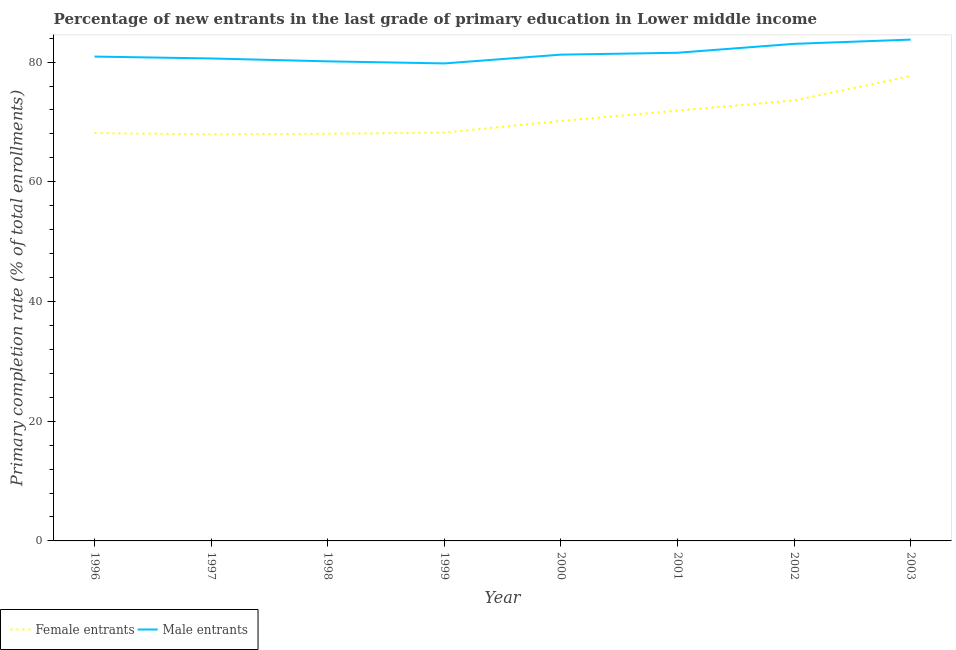What is the primary completion rate of female entrants in 1998?
Keep it short and to the point. 68.03. Across all years, what is the maximum primary completion rate of female entrants?
Ensure brevity in your answer.  77.67. Across all years, what is the minimum primary completion rate of male entrants?
Offer a very short reply. 79.77. In which year was the primary completion rate of male entrants maximum?
Your answer should be compact. 2003. What is the total primary completion rate of female entrants in the graph?
Offer a very short reply. 565.61. What is the difference between the primary completion rate of male entrants in 1996 and that in 2002?
Your answer should be very brief. -2.13. What is the difference between the primary completion rate of female entrants in 1999 and the primary completion rate of male entrants in 2003?
Your response must be concise. -15.53. What is the average primary completion rate of male entrants per year?
Give a very brief answer. 81.38. In the year 1996, what is the difference between the primary completion rate of male entrants and primary completion rate of female entrants?
Your answer should be very brief. 12.78. What is the ratio of the primary completion rate of male entrants in 1996 to that in 2003?
Offer a terse response. 0.97. Is the primary completion rate of female entrants in 1997 less than that in 2000?
Your answer should be compact. Yes. What is the difference between the highest and the second highest primary completion rate of female entrants?
Keep it short and to the point. 4.08. What is the difference between the highest and the lowest primary completion rate of female entrants?
Give a very brief answer. 9.74. In how many years, is the primary completion rate of male entrants greater than the average primary completion rate of male entrants taken over all years?
Provide a succinct answer. 3. Is the sum of the primary completion rate of male entrants in 1996 and 1997 greater than the maximum primary completion rate of female entrants across all years?
Keep it short and to the point. Yes. Does the primary completion rate of male entrants monotonically increase over the years?
Your answer should be compact. No. Is the primary completion rate of female entrants strictly greater than the primary completion rate of male entrants over the years?
Give a very brief answer. No. How many years are there in the graph?
Offer a very short reply. 8. What is the difference between two consecutive major ticks on the Y-axis?
Your answer should be very brief. 20. Are the values on the major ticks of Y-axis written in scientific E-notation?
Your answer should be compact. No. Does the graph contain any zero values?
Give a very brief answer. No. Where does the legend appear in the graph?
Offer a very short reply. Bottom left. What is the title of the graph?
Provide a short and direct response. Percentage of new entrants in the last grade of primary education in Lower middle income. Does "Quasi money growth" appear as one of the legend labels in the graph?
Provide a short and direct response. No. What is the label or title of the Y-axis?
Provide a short and direct response. Primary completion rate (% of total enrollments). What is the Primary completion rate (% of total enrollments) of Female entrants in 1996?
Give a very brief answer. 68.14. What is the Primary completion rate (% of total enrollments) in Male entrants in 1996?
Offer a terse response. 80.92. What is the Primary completion rate (% of total enrollments) in Female entrants in 1997?
Your answer should be compact. 67.92. What is the Primary completion rate (% of total enrollments) of Male entrants in 1997?
Keep it short and to the point. 80.6. What is the Primary completion rate (% of total enrollments) of Female entrants in 1998?
Offer a very short reply. 68.03. What is the Primary completion rate (% of total enrollments) in Male entrants in 1998?
Give a very brief answer. 80.12. What is the Primary completion rate (% of total enrollments) of Female entrants in 1999?
Your response must be concise. 68.22. What is the Primary completion rate (% of total enrollments) in Male entrants in 1999?
Your answer should be very brief. 79.77. What is the Primary completion rate (% of total enrollments) in Female entrants in 2000?
Keep it short and to the point. 70.16. What is the Primary completion rate (% of total enrollments) in Male entrants in 2000?
Give a very brief answer. 81.24. What is the Primary completion rate (% of total enrollments) of Female entrants in 2001?
Give a very brief answer. 71.9. What is the Primary completion rate (% of total enrollments) of Male entrants in 2001?
Offer a very short reply. 81.55. What is the Primary completion rate (% of total enrollments) of Female entrants in 2002?
Provide a short and direct response. 73.58. What is the Primary completion rate (% of total enrollments) of Male entrants in 2002?
Give a very brief answer. 83.04. What is the Primary completion rate (% of total enrollments) in Female entrants in 2003?
Keep it short and to the point. 77.67. What is the Primary completion rate (% of total enrollments) in Male entrants in 2003?
Ensure brevity in your answer.  83.75. Across all years, what is the maximum Primary completion rate (% of total enrollments) in Female entrants?
Offer a terse response. 77.67. Across all years, what is the maximum Primary completion rate (% of total enrollments) in Male entrants?
Provide a succinct answer. 83.75. Across all years, what is the minimum Primary completion rate (% of total enrollments) in Female entrants?
Offer a very short reply. 67.92. Across all years, what is the minimum Primary completion rate (% of total enrollments) in Male entrants?
Your answer should be very brief. 79.77. What is the total Primary completion rate (% of total enrollments) in Female entrants in the graph?
Your answer should be compact. 565.61. What is the total Primary completion rate (% of total enrollments) in Male entrants in the graph?
Keep it short and to the point. 651.01. What is the difference between the Primary completion rate (% of total enrollments) in Female entrants in 1996 and that in 1997?
Your response must be concise. 0.21. What is the difference between the Primary completion rate (% of total enrollments) of Male entrants in 1996 and that in 1997?
Your response must be concise. 0.31. What is the difference between the Primary completion rate (% of total enrollments) of Female entrants in 1996 and that in 1998?
Your answer should be compact. 0.11. What is the difference between the Primary completion rate (% of total enrollments) in Male entrants in 1996 and that in 1998?
Offer a very short reply. 0.8. What is the difference between the Primary completion rate (% of total enrollments) in Female entrants in 1996 and that in 1999?
Offer a very short reply. -0.08. What is the difference between the Primary completion rate (% of total enrollments) of Male entrants in 1996 and that in 1999?
Your answer should be very brief. 1.14. What is the difference between the Primary completion rate (% of total enrollments) in Female entrants in 1996 and that in 2000?
Your answer should be very brief. -2.02. What is the difference between the Primary completion rate (% of total enrollments) of Male entrants in 1996 and that in 2000?
Give a very brief answer. -0.33. What is the difference between the Primary completion rate (% of total enrollments) in Female entrants in 1996 and that in 2001?
Provide a short and direct response. -3.76. What is the difference between the Primary completion rate (% of total enrollments) in Male entrants in 1996 and that in 2001?
Give a very brief answer. -0.64. What is the difference between the Primary completion rate (% of total enrollments) of Female entrants in 1996 and that in 2002?
Give a very brief answer. -5.44. What is the difference between the Primary completion rate (% of total enrollments) in Male entrants in 1996 and that in 2002?
Offer a terse response. -2.13. What is the difference between the Primary completion rate (% of total enrollments) of Female entrants in 1996 and that in 2003?
Make the answer very short. -9.53. What is the difference between the Primary completion rate (% of total enrollments) in Male entrants in 1996 and that in 2003?
Your answer should be compact. -2.84. What is the difference between the Primary completion rate (% of total enrollments) in Female entrants in 1997 and that in 1998?
Offer a very short reply. -0.1. What is the difference between the Primary completion rate (% of total enrollments) in Male entrants in 1997 and that in 1998?
Your answer should be very brief. 0.48. What is the difference between the Primary completion rate (% of total enrollments) of Female entrants in 1997 and that in 1999?
Offer a terse response. -0.3. What is the difference between the Primary completion rate (% of total enrollments) of Male entrants in 1997 and that in 1999?
Ensure brevity in your answer.  0.83. What is the difference between the Primary completion rate (% of total enrollments) of Female entrants in 1997 and that in 2000?
Offer a very short reply. -2.24. What is the difference between the Primary completion rate (% of total enrollments) of Male entrants in 1997 and that in 2000?
Ensure brevity in your answer.  -0.64. What is the difference between the Primary completion rate (% of total enrollments) in Female entrants in 1997 and that in 2001?
Your answer should be very brief. -3.98. What is the difference between the Primary completion rate (% of total enrollments) of Male entrants in 1997 and that in 2001?
Your response must be concise. -0.95. What is the difference between the Primary completion rate (% of total enrollments) in Female entrants in 1997 and that in 2002?
Your answer should be very brief. -5.66. What is the difference between the Primary completion rate (% of total enrollments) in Male entrants in 1997 and that in 2002?
Your response must be concise. -2.44. What is the difference between the Primary completion rate (% of total enrollments) in Female entrants in 1997 and that in 2003?
Keep it short and to the point. -9.74. What is the difference between the Primary completion rate (% of total enrollments) of Male entrants in 1997 and that in 2003?
Ensure brevity in your answer.  -3.15. What is the difference between the Primary completion rate (% of total enrollments) of Female entrants in 1998 and that in 1999?
Your answer should be very brief. -0.19. What is the difference between the Primary completion rate (% of total enrollments) of Male entrants in 1998 and that in 1999?
Keep it short and to the point. 0.35. What is the difference between the Primary completion rate (% of total enrollments) of Female entrants in 1998 and that in 2000?
Your answer should be compact. -2.13. What is the difference between the Primary completion rate (% of total enrollments) in Male entrants in 1998 and that in 2000?
Your answer should be compact. -1.12. What is the difference between the Primary completion rate (% of total enrollments) of Female entrants in 1998 and that in 2001?
Offer a very short reply. -3.87. What is the difference between the Primary completion rate (% of total enrollments) in Male entrants in 1998 and that in 2001?
Give a very brief answer. -1.43. What is the difference between the Primary completion rate (% of total enrollments) of Female entrants in 1998 and that in 2002?
Give a very brief answer. -5.55. What is the difference between the Primary completion rate (% of total enrollments) in Male entrants in 1998 and that in 2002?
Give a very brief answer. -2.92. What is the difference between the Primary completion rate (% of total enrollments) of Female entrants in 1998 and that in 2003?
Provide a short and direct response. -9.64. What is the difference between the Primary completion rate (% of total enrollments) of Male entrants in 1998 and that in 2003?
Provide a short and direct response. -3.63. What is the difference between the Primary completion rate (% of total enrollments) of Female entrants in 1999 and that in 2000?
Provide a succinct answer. -1.94. What is the difference between the Primary completion rate (% of total enrollments) of Male entrants in 1999 and that in 2000?
Your response must be concise. -1.47. What is the difference between the Primary completion rate (% of total enrollments) in Female entrants in 1999 and that in 2001?
Offer a very short reply. -3.68. What is the difference between the Primary completion rate (% of total enrollments) in Male entrants in 1999 and that in 2001?
Offer a very short reply. -1.78. What is the difference between the Primary completion rate (% of total enrollments) of Female entrants in 1999 and that in 2002?
Provide a succinct answer. -5.36. What is the difference between the Primary completion rate (% of total enrollments) in Male entrants in 1999 and that in 2002?
Keep it short and to the point. -3.27. What is the difference between the Primary completion rate (% of total enrollments) of Female entrants in 1999 and that in 2003?
Your response must be concise. -9.45. What is the difference between the Primary completion rate (% of total enrollments) of Male entrants in 1999 and that in 2003?
Offer a very short reply. -3.98. What is the difference between the Primary completion rate (% of total enrollments) of Female entrants in 2000 and that in 2001?
Make the answer very short. -1.74. What is the difference between the Primary completion rate (% of total enrollments) of Male entrants in 2000 and that in 2001?
Ensure brevity in your answer.  -0.31. What is the difference between the Primary completion rate (% of total enrollments) in Female entrants in 2000 and that in 2002?
Offer a terse response. -3.42. What is the difference between the Primary completion rate (% of total enrollments) of Male entrants in 2000 and that in 2002?
Keep it short and to the point. -1.8. What is the difference between the Primary completion rate (% of total enrollments) in Female entrants in 2000 and that in 2003?
Offer a very short reply. -7.51. What is the difference between the Primary completion rate (% of total enrollments) of Male entrants in 2000 and that in 2003?
Make the answer very short. -2.51. What is the difference between the Primary completion rate (% of total enrollments) of Female entrants in 2001 and that in 2002?
Offer a terse response. -1.68. What is the difference between the Primary completion rate (% of total enrollments) in Male entrants in 2001 and that in 2002?
Provide a succinct answer. -1.49. What is the difference between the Primary completion rate (% of total enrollments) of Female entrants in 2001 and that in 2003?
Provide a short and direct response. -5.77. What is the difference between the Primary completion rate (% of total enrollments) in Male entrants in 2001 and that in 2003?
Provide a short and direct response. -2.2. What is the difference between the Primary completion rate (% of total enrollments) in Female entrants in 2002 and that in 2003?
Make the answer very short. -4.08. What is the difference between the Primary completion rate (% of total enrollments) in Male entrants in 2002 and that in 2003?
Ensure brevity in your answer.  -0.71. What is the difference between the Primary completion rate (% of total enrollments) in Female entrants in 1996 and the Primary completion rate (% of total enrollments) in Male entrants in 1997?
Make the answer very short. -12.47. What is the difference between the Primary completion rate (% of total enrollments) of Female entrants in 1996 and the Primary completion rate (% of total enrollments) of Male entrants in 1998?
Your answer should be compact. -11.98. What is the difference between the Primary completion rate (% of total enrollments) in Female entrants in 1996 and the Primary completion rate (% of total enrollments) in Male entrants in 1999?
Offer a very short reply. -11.64. What is the difference between the Primary completion rate (% of total enrollments) of Female entrants in 1996 and the Primary completion rate (% of total enrollments) of Male entrants in 2000?
Keep it short and to the point. -13.1. What is the difference between the Primary completion rate (% of total enrollments) in Female entrants in 1996 and the Primary completion rate (% of total enrollments) in Male entrants in 2001?
Your answer should be very brief. -13.42. What is the difference between the Primary completion rate (% of total enrollments) in Female entrants in 1996 and the Primary completion rate (% of total enrollments) in Male entrants in 2002?
Make the answer very short. -14.91. What is the difference between the Primary completion rate (% of total enrollments) of Female entrants in 1996 and the Primary completion rate (% of total enrollments) of Male entrants in 2003?
Provide a short and direct response. -15.62. What is the difference between the Primary completion rate (% of total enrollments) in Female entrants in 1997 and the Primary completion rate (% of total enrollments) in Male entrants in 1998?
Make the answer very short. -12.2. What is the difference between the Primary completion rate (% of total enrollments) in Female entrants in 1997 and the Primary completion rate (% of total enrollments) in Male entrants in 1999?
Provide a succinct answer. -11.85. What is the difference between the Primary completion rate (% of total enrollments) in Female entrants in 1997 and the Primary completion rate (% of total enrollments) in Male entrants in 2000?
Ensure brevity in your answer.  -13.32. What is the difference between the Primary completion rate (% of total enrollments) of Female entrants in 1997 and the Primary completion rate (% of total enrollments) of Male entrants in 2001?
Your answer should be compact. -13.63. What is the difference between the Primary completion rate (% of total enrollments) of Female entrants in 1997 and the Primary completion rate (% of total enrollments) of Male entrants in 2002?
Give a very brief answer. -15.12. What is the difference between the Primary completion rate (% of total enrollments) of Female entrants in 1997 and the Primary completion rate (% of total enrollments) of Male entrants in 2003?
Provide a short and direct response. -15.83. What is the difference between the Primary completion rate (% of total enrollments) of Female entrants in 1998 and the Primary completion rate (% of total enrollments) of Male entrants in 1999?
Your answer should be very brief. -11.75. What is the difference between the Primary completion rate (% of total enrollments) of Female entrants in 1998 and the Primary completion rate (% of total enrollments) of Male entrants in 2000?
Provide a short and direct response. -13.22. What is the difference between the Primary completion rate (% of total enrollments) of Female entrants in 1998 and the Primary completion rate (% of total enrollments) of Male entrants in 2001?
Ensure brevity in your answer.  -13.53. What is the difference between the Primary completion rate (% of total enrollments) of Female entrants in 1998 and the Primary completion rate (% of total enrollments) of Male entrants in 2002?
Your response must be concise. -15.02. What is the difference between the Primary completion rate (% of total enrollments) of Female entrants in 1998 and the Primary completion rate (% of total enrollments) of Male entrants in 2003?
Provide a succinct answer. -15.73. What is the difference between the Primary completion rate (% of total enrollments) of Female entrants in 1999 and the Primary completion rate (% of total enrollments) of Male entrants in 2000?
Make the answer very short. -13.02. What is the difference between the Primary completion rate (% of total enrollments) of Female entrants in 1999 and the Primary completion rate (% of total enrollments) of Male entrants in 2001?
Your answer should be very brief. -13.34. What is the difference between the Primary completion rate (% of total enrollments) in Female entrants in 1999 and the Primary completion rate (% of total enrollments) in Male entrants in 2002?
Give a very brief answer. -14.82. What is the difference between the Primary completion rate (% of total enrollments) of Female entrants in 1999 and the Primary completion rate (% of total enrollments) of Male entrants in 2003?
Offer a terse response. -15.53. What is the difference between the Primary completion rate (% of total enrollments) in Female entrants in 2000 and the Primary completion rate (% of total enrollments) in Male entrants in 2001?
Your response must be concise. -11.39. What is the difference between the Primary completion rate (% of total enrollments) in Female entrants in 2000 and the Primary completion rate (% of total enrollments) in Male entrants in 2002?
Ensure brevity in your answer.  -12.88. What is the difference between the Primary completion rate (% of total enrollments) of Female entrants in 2000 and the Primary completion rate (% of total enrollments) of Male entrants in 2003?
Provide a short and direct response. -13.59. What is the difference between the Primary completion rate (% of total enrollments) of Female entrants in 2001 and the Primary completion rate (% of total enrollments) of Male entrants in 2002?
Your answer should be compact. -11.14. What is the difference between the Primary completion rate (% of total enrollments) in Female entrants in 2001 and the Primary completion rate (% of total enrollments) in Male entrants in 2003?
Offer a terse response. -11.85. What is the difference between the Primary completion rate (% of total enrollments) in Female entrants in 2002 and the Primary completion rate (% of total enrollments) in Male entrants in 2003?
Offer a very short reply. -10.17. What is the average Primary completion rate (% of total enrollments) of Female entrants per year?
Make the answer very short. 70.7. What is the average Primary completion rate (% of total enrollments) of Male entrants per year?
Your answer should be compact. 81.38. In the year 1996, what is the difference between the Primary completion rate (% of total enrollments) in Female entrants and Primary completion rate (% of total enrollments) in Male entrants?
Provide a succinct answer. -12.78. In the year 1997, what is the difference between the Primary completion rate (% of total enrollments) in Female entrants and Primary completion rate (% of total enrollments) in Male entrants?
Offer a very short reply. -12.68. In the year 1998, what is the difference between the Primary completion rate (% of total enrollments) in Female entrants and Primary completion rate (% of total enrollments) in Male entrants?
Ensure brevity in your answer.  -12.09. In the year 1999, what is the difference between the Primary completion rate (% of total enrollments) of Female entrants and Primary completion rate (% of total enrollments) of Male entrants?
Offer a very short reply. -11.55. In the year 2000, what is the difference between the Primary completion rate (% of total enrollments) of Female entrants and Primary completion rate (% of total enrollments) of Male entrants?
Offer a very short reply. -11.08. In the year 2001, what is the difference between the Primary completion rate (% of total enrollments) in Female entrants and Primary completion rate (% of total enrollments) in Male entrants?
Offer a terse response. -9.65. In the year 2002, what is the difference between the Primary completion rate (% of total enrollments) of Female entrants and Primary completion rate (% of total enrollments) of Male entrants?
Provide a short and direct response. -9.46. In the year 2003, what is the difference between the Primary completion rate (% of total enrollments) in Female entrants and Primary completion rate (% of total enrollments) in Male entrants?
Ensure brevity in your answer.  -6.09. What is the ratio of the Primary completion rate (% of total enrollments) in Female entrants in 1996 to that in 1997?
Your answer should be compact. 1. What is the ratio of the Primary completion rate (% of total enrollments) of Male entrants in 1996 to that in 1997?
Keep it short and to the point. 1. What is the ratio of the Primary completion rate (% of total enrollments) of Female entrants in 1996 to that in 1998?
Ensure brevity in your answer.  1. What is the ratio of the Primary completion rate (% of total enrollments) of Male entrants in 1996 to that in 1998?
Ensure brevity in your answer.  1.01. What is the ratio of the Primary completion rate (% of total enrollments) in Female entrants in 1996 to that in 1999?
Keep it short and to the point. 1. What is the ratio of the Primary completion rate (% of total enrollments) of Male entrants in 1996 to that in 1999?
Provide a short and direct response. 1.01. What is the ratio of the Primary completion rate (% of total enrollments) of Female entrants in 1996 to that in 2000?
Your answer should be compact. 0.97. What is the ratio of the Primary completion rate (% of total enrollments) in Male entrants in 1996 to that in 2000?
Keep it short and to the point. 1. What is the ratio of the Primary completion rate (% of total enrollments) in Female entrants in 1996 to that in 2001?
Your answer should be very brief. 0.95. What is the ratio of the Primary completion rate (% of total enrollments) in Male entrants in 1996 to that in 2001?
Your answer should be very brief. 0.99. What is the ratio of the Primary completion rate (% of total enrollments) of Female entrants in 1996 to that in 2002?
Offer a very short reply. 0.93. What is the ratio of the Primary completion rate (% of total enrollments) of Male entrants in 1996 to that in 2002?
Keep it short and to the point. 0.97. What is the ratio of the Primary completion rate (% of total enrollments) in Female entrants in 1996 to that in 2003?
Give a very brief answer. 0.88. What is the ratio of the Primary completion rate (% of total enrollments) in Male entrants in 1996 to that in 2003?
Provide a succinct answer. 0.97. What is the ratio of the Primary completion rate (% of total enrollments) of Female entrants in 1997 to that in 1998?
Make the answer very short. 1. What is the ratio of the Primary completion rate (% of total enrollments) in Male entrants in 1997 to that in 1999?
Ensure brevity in your answer.  1.01. What is the ratio of the Primary completion rate (% of total enrollments) of Female entrants in 1997 to that in 2000?
Ensure brevity in your answer.  0.97. What is the ratio of the Primary completion rate (% of total enrollments) of Male entrants in 1997 to that in 2000?
Ensure brevity in your answer.  0.99. What is the ratio of the Primary completion rate (% of total enrollments) in Female entrants in 1997 to that in 2001?
Make the answer very short. 0.94. What is the ratio of the Primary completion rate (% of total enrollments) of Male entrants in 1997 to that in 2001?
Your answer should be compact. 0.99. What is the ratio of the Primary completion rate (% of total enrollments) in Female entrants in 1997 to that in 2002?
Offer a very short reply. 0.92. What is the ratio of the Primary completion rate (% of total enrollments) of Male entrants in 1997 to that in 2002?
Provide a succinct answer. 0.97. What is the ratio of the Primary completion rate (% of total enrollments) in Female entrants in 1997 to that in 2003?
Offer a terse response. 0.87. What is the ratio of the Primary completion rate (% of total enrollments) of Male entrants in 1997 to that in 2003?
Make the answer very short. 0.96. What is the ratio of the Primary completion rate (% of total enrollments) in Male entrants in 1998 to that in 1999?
Your answer should be compact. 1. What is the ratio of the Primary completion rate (% of total enrollments) in Female entrants in 1998 to that in 2000?
Ensure brevity in your answer.  0.97. What is the ratio of the Primary completion rate (% of total enrollments) of Male entrants in 1998 to that in 2000?
Your response must be concise. 0.99. What is the ratio of the Primary completion rate (% of total enrollments) in Female entrants in 1998 to that in 2001?
Keep it short and to the point. 0.95. What is the ratio of the Primary completion rate (% of total enrollments) in Male entrants in 1998 to that in 2001?
Offer a very short reply. 0.98. What is the ratio of the Primary completion rate (% of total enrollments) in Female entrants in 1998 to that in 2002?
Your response must be concise. 0.92. What is the ratio of the Primary completion rate (% of total enrollments) of Male entrants in 1998 to that in 2002?
Make the answer very short. 0.96. What is the ratio of the Primary completion rate (% of total enrollments) in Female entrants in 1998 to that in 2003?
Your answer should be compact. 0.88. What is the ratio of the Primary completion rate (% of total enrollments) in Male entrants in 1998 to that in 2003?
Your answer should be very brief. 0.96. What is the ratio of the Primary completion rate (% of total enrollments) in Female entrants in 1999 to that in 2000?
Offer a very short reply. 0.97. What is the ratio of the Primary completion rate (% of total enrollments) of Male entrants in 1999 to that in 2000?
Provide a short and direct response. 0.98. What is the ratio of the Primary completion rate (% of total enrollments) of Female entrants in 1999 to that in 2001?
Make the answer very short. 0.95. What is the ratio of the Primary completion rate (% of total enrollments) in Male entrants in 1999 to that in 2001?
Provide a succinct answer. 0.98. What is the ratio of the Primary completion rate (% of total enrollments) in Female entrants in 1999 to that in 2002?
Offer a very short reply. 0.93. What is the ratio of the Primary completion rate (% of total enrollments) of Male entrants in 1999 to that in 2002?
Make the answer very short. 0.96. What is the ratio of the Primary completion rate (% of total enrollments) in Female entrants in 1999 to that in 2003?
Provide a succinct answer. 0.88. What is the ratio of the Primary completion rate (% of total enrollments) of Male entrants in 1999 to that in 2003?
Offer a terse response. 0.95. What is the ratio of the Primary completion rate (% of total enrollments) in Female entrants in 2000 to that in 2001?
Your response must be concise. 0.98. What is the ratio of the Primary completion rate (% of total enrollments) in Female entrants in 2000 to that in 2002?
Provide a short and direct response. 0.95. What is the ratio of the Primary completion rate (% of total enrollments) of Male entrants in 2000 to that in 2002?
Offer a terse response. 0.98. What is the ratio of the Primary completion rate (% of total enrollments) in Female entrants in 2000 to that in 2003?
Give a very brief answer. 0.9. What is the ratio of the Primary completion rate (% of total enrollments) of Female entrants in 2001 to that in 2002?
Offer a terse response. 0.98. What is the ratio of the Primary completion rate (% of total enrollments) of Male entrants in 2001 to that in 2002?
Keep it short and to the point. 0.98. What is the ratio of the Primary completion rate (% of total enrollments) of Female entrants in 2001 to that in 2003?
Provide a succinct answer. 0.93. What is the ratio of the Primary completion rate (% of total enrollments) in Male entrants in 2001 to that in 2003?
Give a very brief answer. 0.97. What is the ratio of the Primary completion rate (% of total enrollments) of Female entrants in 2002 to that in 2003?
Keep it short and to the point. 0.95. What is the ratio of the Primary completion rate (% of total enrollments) of Male entrants in 2002 to that in 2003?
Make the answer very short. 0.99. What is the difference between the highest and the second highest Primary completion rate (% of total enrollments) of Female entrants?
Give a very brief answer. 4.08. What is the difference between the highest and the second highest Primary completion rate (% of total enrollments) in Male entrants?
Make the answer very short. 0.71. What is the difference between the highest and the lowest Primary completion rate (% of total enrollments) of Female entrants?
Your response must be concise. 9.74. What is the difference between the highest and the lowest Primary completion rate (% of total enrollments) in Male entrants?
Keep it short and to the point. 3.98. 